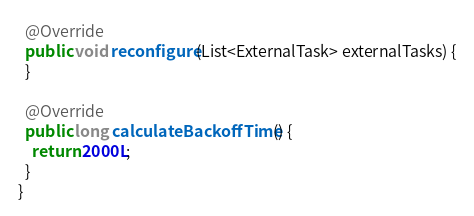<code> <loc_0><loc_0><loc_500><loc_500><_Java_>
  @Override
  public void reconfigure(List<ExternalTask> externalTasks) {
  }

  @Override
  public long calculateBackoffTime() {
    return 2000L;
  }
}
</code> 